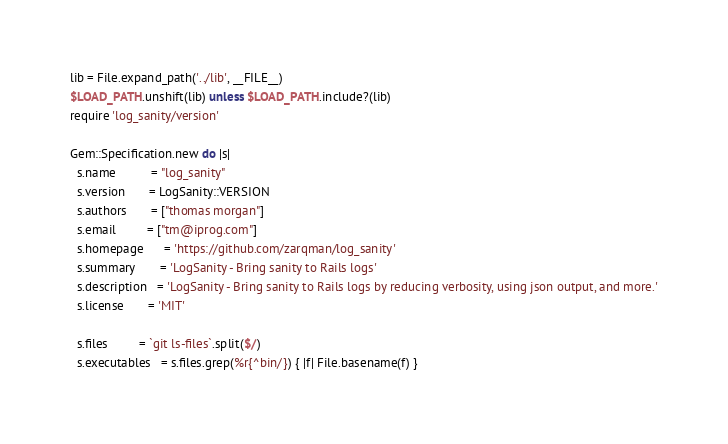<code> <loc_0><loc_0><loc_500><loc_500><_Ruby_>lib = File.expand_path('../lib', __FILE__)
$LOAD_PATH.unshift(lib) unless $LOAD_PATH.include?(lib)
require 'log_sanity/version'

Gem::Specification.new do |s|
  s.name          = "log_sanity"
  s.version       = LogSanity::VERSION
  s.authors       = ["thomas morgan"]
  s.email         = ["tm@iprog.com"]
  s.homepage      = 'https://github.com/zarqman/log_sanity'
  s.summary       = 'LogSanity - Bring sanity to Rails logs'
  s.description   = 'LogSanity - Bring sanity to Rails logs by reducing verbosity, using json output, and more.'
  s.license       = 'MIT'

  s.files         = `git ls-files`.split($/)
  s.executables   = s.files.grep(%r{^bin/}) { |f| File.basename(f) }</code> 